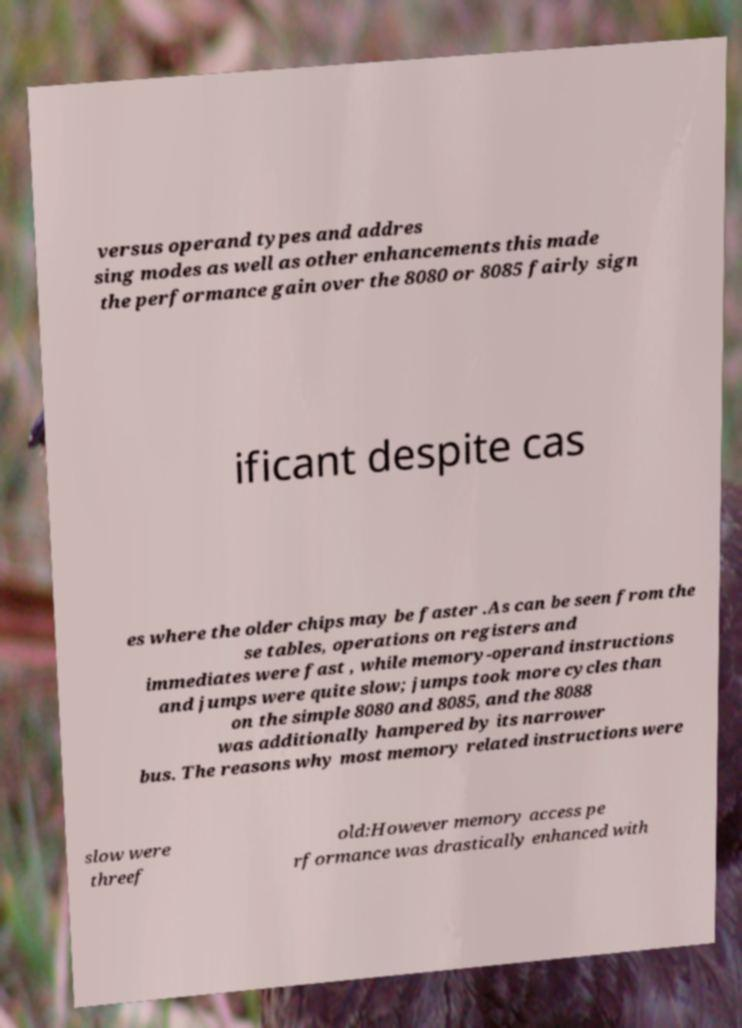Could you extract and type out the text from this image? versus operand types and addres sing modes as well as other enhancements this made the performance gain over the 8080 or 8085 fairly sign ificant despite cas es where the older chips may be faster .As can be seen from the se tables, operations on registers and immediates were fast , while memory-operand instructions and jumps were quite slow; jumps took more cycles than on the simple 8080 and 8085, and the 8088 was additionally hampered by its narrower bus. The reasons why most memory related instructions were slow were threef old:However memory access pe rformance was drastically enhanced with 